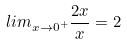<formula> <loc_0><loc_0><loc_500><loc_500>l i m _ { x \rightarrow 0 ^ { + } } \frac { 2 x } { x } = 2</formula> 